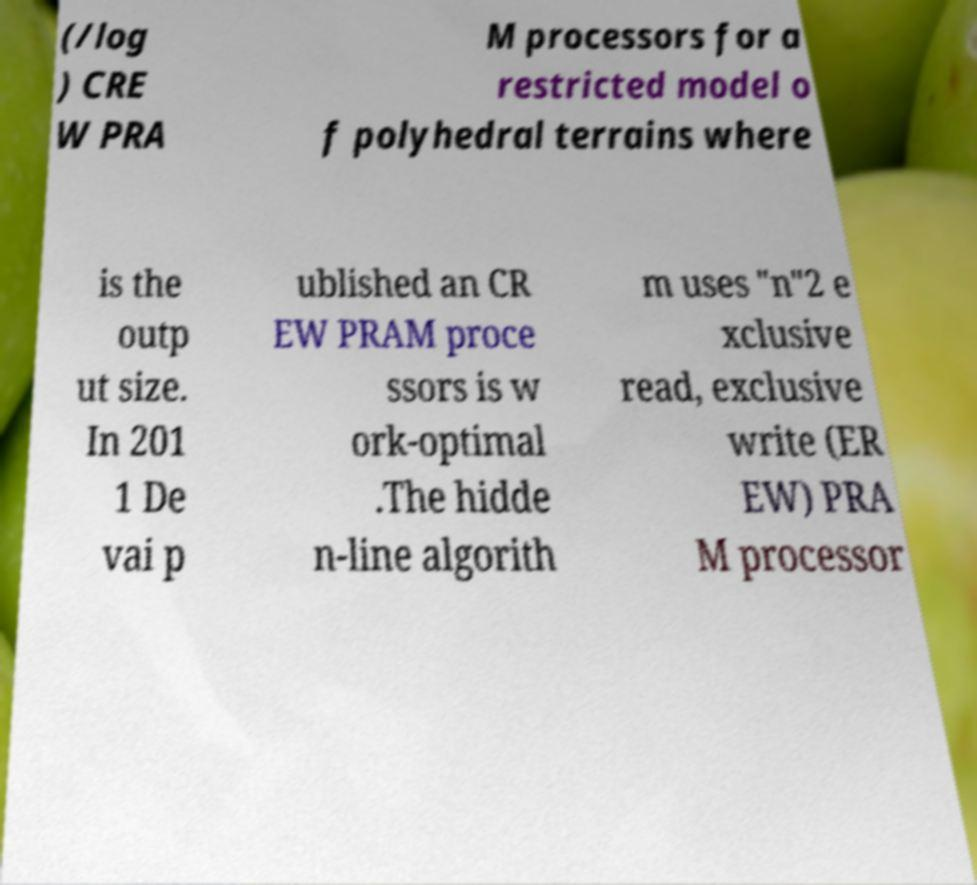Please read and relay the text visible in this image. What does it say? (/log ) CRE W PRA M processors for a restricted model o f polyhedral terrains where is the outp ut size. In 201 1 De vai p ublished an CR EW PRAM proce ssors is w ork-optimal .The hidde n-line algorith m uses "n"2 e xclusive read, exclusive write (ER EW) PRA M processor 